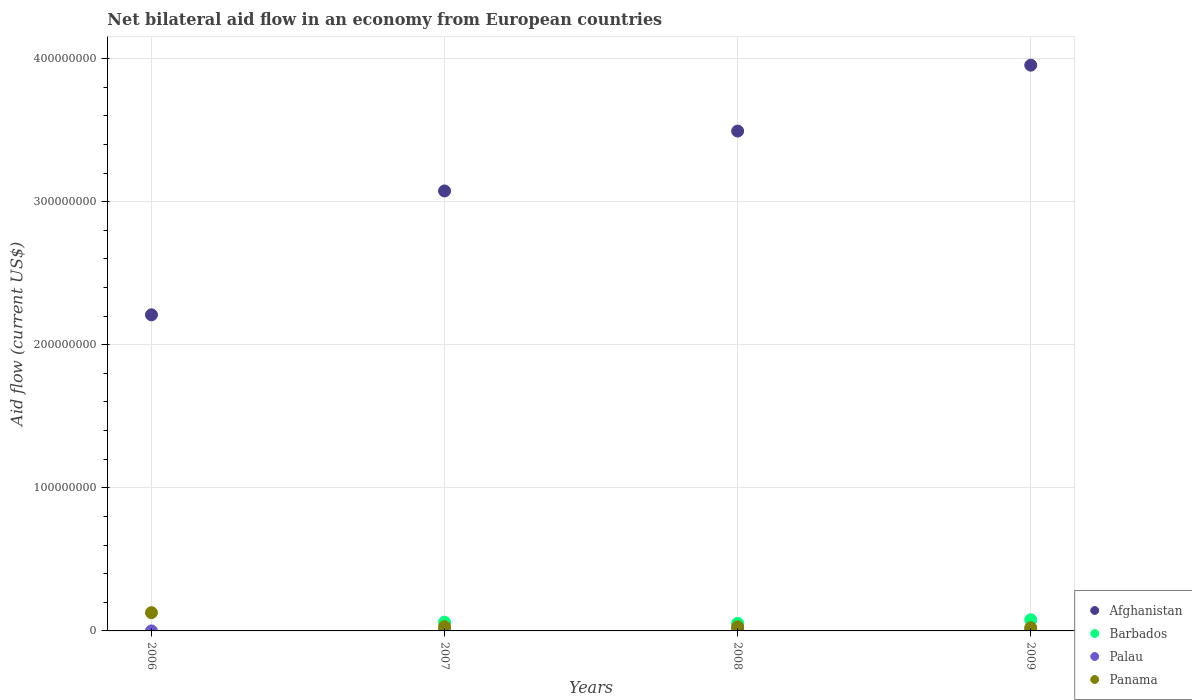How many different coloured dotlines are there?
Offer a very short reply. 4. Is the number of dotlines equal to the number of legend labels?
Offer a very short reply. No. What is the net bilateral aid flow in Palau in 2009?
Provide a short and direct response. 5.90e+05. Across all years, what is the maximum net bilateral aid flow in Palau?
Make the answer very short. 1.28e+06. Across all years, what is the minimum net bilateral aid flow in Afghanistan?
Make the answer very short. 2.21e+08. What is the total net bilateral aid flow in Afghanistan in the graph?
Make the answer very short. 1.27e+09. What is the difference between the net bilateral aid flow in Barbados in 2007 and that in 2009?
Offer a terse response. -1.68e+06. What is the difference between the net bilateral aid flow in Palau in 2009 and the net bilateral aid flow in Barbados in 2008?
Give a very brief answer. -4.70e+06. What is the average net bilateral aid flow in Afghanistan per year?
Offer a very short reply. 3.18e+08. In the year 2009, what is the difference between the net bilateral aid flow in Palau and net bilateral aid flow in Barbados?
Ensure brevity in your answer.  -7.18e+06. In how many years, is the net bilateral aid flow in Panama greater than 360000000 US$?
Keep it short and to the point. 0. What is the ratio of the net bilateral aid flow in Palau in 2007 to that in 2008?
Provide a succinct answer. 0.26. Is the difference between the net bilateral aid flow in Palau in 2007 and 2009 greater than the difference between the net bilateral aid flow in Barbados in 2007 and 2009?
Keep it short and to the point. Yes. What is the difference between the highest and the second highest net bilateral aid flow in Panama?
Ensure brevity in your answer.  9.80e+06. What is the difference between the highest and the lowest net bilateral aid flow in Palau?
Offer a very short reply. 1.26e+06. Is the sum of the net bilateral aid flow in Panama in 2007 and 2009 greater than the maximum net bilateral aid flow in Barbados across all years?
Provide a succinct answer. No. Does the net bilateral aid flow in Palau monotonically increase over the years?
Ensure brevity in your answer.  No. Is the net bilateral aid flow in Palau strictly greater than the net bilateral aid flow in Afghanistan over the years?
Your answer should be very brief. No. What is the difference between two consecutive major ticks on the Y-axis?
Keep it short and to the point. 1.00e+08. Does the graph contain any zero values?
Offer a very short reply. Yes. Where does the legend appear in the graph?
Your response must be concise. Bottom right. How many legend labels are there?
Make the answer very short. 4. How are the legend labels stacked?
Ensure brevity in your answer.  Vertical. What is the title of the graph?
Your answer should be very brief. Net bilateral aid flow in an economy from European countries. Does "Norway" appear as one of the legend labels in the graph?
Provide a succinct answer. No. What is the label or title of the X-axis?
Your answer should be compact. Years. What is the Aid flow (current US$) in Afghanistan in 2006?
Your response must be concise. 2.21e+08. What is the Aid flow (current US$) of Panama in 2006?
Your response must be concise. 1.28e+07. What is the Aid flow (current US$) of Afghanistan in 2007?
Your answer should be compact. 3.07e+08. What is the Aid flow (current US$) in Barbados in 2007?
Give a very brief answer. 6.09e+06. What is the Aid flow (current US$) in Palau in 2007?
Provide a succinct answer. 3.30e+05. What is the Aid flow (current US$) in Panama in 2007?
Offer a very short reply. 2.96e+06. What is the Aid flow (current US$) of Afghanistan in 2008?
Ensure brevity in your answer.  3.49e+08. What is the Aid flow (current US$) in Barbados in 2008?
Ensure brevity in your answer.  5.29e+06. What is the Aid flow (current US$) of Palau in 2008?
Provide a succinct answer. 1.28e+06. What is the Aid flow (current US$) of Panama in 2008?
Ensure brevity in your answer.  2.84e+06. What is the Aid flow (current US$) of Afghanistan in 2009?
Give a very brief answer. 3.95e+08. What is the Aid flow (current US$) of Barbados in 2009?
Your answer should be very brief. 7.77e+06. What is the Aid flow (current US$) of Palau in 2009?
Offer a very short reply. 5.90e+05. What is the Aid flow (current US$) of Panama in 2009?
Ensure brevity in your answer.  2.23e+06. Across all years, what is the maximum Aid flow (current US$) of Afghanistan?
Offer a very short reply. 3.95e+08. Across all years, what is the maximum Aid flow (current US$) in Barbados?
Ensure brevity in your answer.  7.77e+06. Across all years, what is the maximum Aid flow (current US$) of Palau?
Make the answer very short. 1.28e+06. Across all years, what is the maximum Aid flow (current US$) of Panama?
Your answer should be very brief. 1.28e+07. Across all years, what is the minimum Aid flow (current US$) in Afghanistan?
Offer a terse response. 2.21e+08. Across all years, what is the minimum Aid flow (current US$) in Palau?
Your answer should be very brief. 2.00e+04. Across all years, what is the minimum Aid flow (current US$) of Panama?
Your response must be concise. 2.23e+06. What is the total Aid flow (current US$) in Afghanistan in the graph?
Your response must be concise. 1.27e+09. What is the total Aid flow (current US$) of Barbados in the graph?
Offer a very short reply. 1.92e+07. What is the total Aid flow (current US$) in Palau in the graph?
Your answer should be compact. 2.22e+06. What is the total Aid flow (current US$) in Panama in the graph?
Give a very brief answer. 2.08e+07. What is the difference between the Aid flow (current US$) in Afghanistan in 2006 and that in 2007?
Your response must be concise. -8.66e+07. What is the difference between the Aid flow (current US$) in Palau in 2006 and that in 2007?
Make the answer very short. -3.10e+05. What is the difference between the Aid flow (current US$) in Panama in 2006 and that in 2007?
Provide a succinct answer. 9.80e+06. What is the difference between the Aid flow (current US$) in Afghanistan in 2006 and that in 2008?
Offer a very short reply. -1.28e+08. What is the difference between the Aid flow (current US$) of Palau in 2006 and that in 2008?
Provide a short and direct response. -1.26e+06. What is the difference between the Aid flow (current US$) in Panama in 2006 and that in 2008?
Provide a succinct answer. 9.92e+06. What is the difference between the Aid flow (current US$) in Afghanistan in 2006 and that in 2009?
Offer a very short reply. -1.74e+08. What is the difference between the Aid flow (current US$) in Palau in 2006 and that in 2009?
Provide a succinct answer. -5.70e+05. What is the difference between the Aid flow (current US$) of Panama in 2006 and that in 2009?
Your answer should be very brief. 1.05e+07. What is the difference between the Aid flow (current US$) of Afghanistan in 2007 and that in 2008?
Your answer should be very brief. -4.18e+07. What is the difference between the Aid flow (current US$) of Palau in 2007 and that in 2008?
Provide a short and direct response. -9.50e+05. What is the difference between the Aid flow (current US$) of Afghanistan in 2007 and that in 2009?
Offer a terse response. -8.79e+07. What is the difference between the Aid flow (current US$) of Barbados in 2007 and that in 2009?
Offer a terse response. -1.68e+06. What is the difference between the Aid flow (current US$) of Panama in 2007 and that in 2009?
Provide a succinct answer. 7.30e+05. What is the difference between the Aid flow (current US$) of Afghanistan in 2008 and that in 2009?
Your answer should be compact. -4.60e+07. What is the difference between the Aid flow (current US$) of Barbados in 2008 and that in 2009?
Make the answer very short. -2.48e+06. What is the difference between the Aid flow (current US$) in Palau in 2008 and that in 2009?
Provide a succinct answer. 6.90e+05. What is the difference between the Aid flow (current US$) of Afghanistan in 2006 and the Aid flow (current US$) of Barbados in 2007?
Offer a terse response. 2.15e+08. What is the difference between the Aid flow (current US$) of Afghanistan in 2006 and the Aid flow (current US$) of Palau in 2007?
Ensure brevity in your answer.  2.21e+08. What is the difference between the Aid flow (current US$) of Afghanistan in 2006 and the Aid flow (current US$) of Panama in 2007?
Make the answer very short. 2.18e+08. What is the difference between the Aid flow (current US$) in Palau in 2006 and the Aid flow (current US$) in Panama in 2007?
Provide a short and direct response. -2.94e+06. What is the difference between the Aid flow (current US$) in Afghanistan in 2006 and the Aid flow (current US$) in Barbados in 2008?
Provide a succinct answer. 2.16e+08. What is the difference between the Aid flow (current US$) of Afghanistan in 2006 and the Aid flow (current US$) of Palau in 2008?
Offer a terse response. 2.20e+08. What is the difference between the Aid flow (current US$) of Afghanistan in 2006 and the Aid flow (current US$) of Panama in 2008?
Your answer should be very brief. 2.18e+08. What is the difference between the Aid flow (current US$) in Palau in 2006 and the Aid flow (current US$) in Panama in 2008?
Your answer should be compact. -2.82e+06. What is the difference between the Aid flow (current US$) of Afghanistan in 2006 and the Aid flow (current US$) of Barbados in 2009?
Your response must be concise. 2.13e+08. What is the difference between the Aid flow (current US$) of Afghanistan in 2006 and the Aid flow (current US$) of Palau in 2009?
Make the answer very short. 2.20e+08. What is the difference between the Aid flow (current US$) of Afghanistan in 2006 and the Aid flow (current US$) of Panama in 2009?
Your answer should be very brief. 2.19e+08. What is the difference between the Aid flow (current US$) in Palau in 2006 and the Aid flow (current US$) in Panama in 2009?
Provide a short and direct response. -2.21e+06. What is the difference between the Aid flow (current US$) of Afghanistan in 2007 and the Aid flow (current US$) of Barbados in 2008?
Offer a very short reply. 3.02e+08. What is the difference between the Aid flow (current US$) in Afghanistan in 2007 and the Aid flow (current US$) in Palau in 2008?
Offer a terse response. 3.06e+08. What is the difference between the Aid flow (current US$) in Afghanistan in 2007 and the Aid flow (current US$) in Panama in 2008?
Provide a succinct answer. 3.05e+08. What is the difference between the Aid flow (current US$) in Barbados in 2007 and the Aid flow (current US$) in Palau in 2008?
Your answer should be very brief. 4.81e+06. What is the difference between the Aid flow (current US$) in Barbados in 2007 and the Aid flow (current US$) in Panama in 2008?
Ensure brevity in your answer.  3.25e+06. What is the difference between the Aid flow (current US$) of Palau in 2007 and the Aid flow (current US$) of Panama in 2008?
Give a very brief answer. -2.51e+06. What is the difference between the Aid flow (current US$) of Afghanistan in 2007 and the Aid flow (current US$) of Barbados in 2009?
Keep it short and to the point. 3.00e+08. What is the difference between the Aid flow (current US$) in Afghanistan in 2007 and the Aid flow (current US$) in Palau in 2009?
Provide a short and direct response. 3.07e+08. What is the difference between the Aid flow (current US$) of Afghanistan in 2007 and the Aid flow (current US$) of Panama in 2009?
Your response must be concise. 3.05e+08. What is the difference between the Aid flow (current US$) of Barbados in 2007 and the Aid flow (current US$) of Palau in 2009?
Give a very brief answer. 5.50e+06. What is the difference between the Aid flow (current US$) of Barbados in 2007 and the Aid flow (current US$) of Panama in 2009?
Ensure brevity in your answer.  3.86e+06. What is the difference between the Aid flow (current US$) of Palau in 2007 and the Aid flow (current US$) of Panama in 2009?
Give a very brief answer. -1.90e+06. What is the difference between the Aid flow (current US$) in Afghanistan in 2008 and the Aid flow (current US$) in Barbados in 2009?
Your response must be concise. 3.42e+08. What is the difference between the Aid flow (current US$) of Afghanistan in 2008 and the Aid flow (current US$) of Palau in 2009?
Ensure brevity in your answer.  3.49e+08. What is the difference between the Aid flow (current US$) in Afghanistan in 2008 and the Aid flow (current US$) in Panama in 2009?
Your response must be concise. 3.47e+08. What is the difference between the Aid flow (current US$) in Barbados in 2008 and the Aid flow (current US$) in Palau in 2009?
Your answer should be very brief. 4.70e+06. What is the difference between the Aid flow (current US$) of Barbados in 2008 and the Aid flow (current US$) of Panama in 2009?
Offer a very short reply. 3.06e+06. What is the difference between the Aid flow (current US$) of Palau in 2008 and the Aid flow (current US$) of Panama in 2009?
Offer a very short reply. -9.50e+05. What is the average Aid flow (current US$) in Afghanistan per year?
Offer a terse response. 3.18e+08. What is the average Aid flow (current US$) of Barbados per year?
Ensure brevity in your answer.  4.79e+06. What is the average Aid flow (current US$) of Palau per year?
Provide a short and direct response. 5.55e+05. What is the average Aid flow (current US$) of Panama per year?
Offer a very short reply. 5.20e+06. In the year 2006, what is the difference between the Aid flow (current US$) of Afghanistan and Aid flow (current US$) of Palau?
Keep it short and to the point. 2.21e+08. In the year 2006, what is the difference between the Aid flow (current US$) in Afghanistan and Aid flow (current US$) in Panama?
Your answer should be very brief. 2.08e+08. In the year 2006, what is the difference between the Aid flow (current US$) in Palau and Aid flow (current US$) in Panama?
Your answer should be compact. -1.27e+07. In the year 2007, what is the difference between the Aid flow (current US$) in Afghanistan and Aid flow (current US$) in Barbados?
Provide a succinct answer. 3.01e+08. In the year 2007, what is the difference between the Aid flow (current US$) in Afghanistan and Aid flow (current US$) in Palau?
Provide a succinct answer. 3.07e+08. In the year 2007, what is the difference between the Aid flow (current US$) of Afghanistan and Aid flow (current US$) of Panama?
Your answer should be very brief. 3.04e+08. In the year 2007, what is the difference between the Aid flow (current US$) in Barbados and Aid flow (current US$) in Palau?
Ensure brevity in your answer.  5.76e+06. In the year 2007, what is the difference between the Aid flow (current US$) in Barbados and Aid flow (current US$) in Panama?
Provide a short and direct response. 3.13e+06. In the year 2007, what is the difference between the Aid flow (current US$) in Palau and Aid flow (current US$) in Panama?
Your response must be concise. -2.63e+06. In the year 2008, what is the difference between the Aid flow (current US$) of Afghanistan and Aid flow (current US$) of Barbados?
Keep it short and to the point. 3.44e+08. In the year 2008, what is the difference between the Aid flow (current US$) of Afghanistan and Aid flow (current US$) of Palau?
Your response must be concise. 3.48e+08. In the year 2008, what is the difference between the Aid flow (current US$) in Afghanistan and Aid flow (current US$) in Panama?
Your answer should be compact. 3.46e+08. In the year 2008, what is the difference between the Aid flow (current US$) of Barbados and Aid flow (current US$) of Palau?
Offer a very short reply. 4.01e+06. In the year 2008, what is the difference between the Aid flow (current US$) of Barbados and Aid flow (current US$) of Panama?
Give a very brief answer. 2.45e+06. In the year 2008, what is the difference between the Aid flow (current US$) of Palau and Aid flow (current US$) of Panama?
Your answer should be very brief. -1.56e+06. In the year 2009, what is the difference between the Aid flow (current US$) of Afghanistan and Aid flow (current US$) of Barbados?
Your answer should be very brief. 3.88e+08. In the year 2009, what is the difference between the Aid flow (current US$) of Afghanistan and Aid flow (current US$) of Palau?
Your response must be concise. 3.95e+08. In the year 2009, what is the difference between the Aid flow (current US$) in Afghanistan and Aid flow (current US$) in Panama?
Ensure brevity in your answer.  3.93e+08. In the year 2009, what is the difference between the Aid flow (current US$) of Barbados and Aid flow (current US$) of Palau?
Ensure brevity in your answer.  7.18e+06. In the year 2009, what is the difference between the Aid flow (current US$) of Barbados and Aid flow (current US$) of Panama?
Offer a very short reply. 5.54e+06. In the year 2009, what is the difference between the Aid flow (current US$) in Palau and Aid flow (current US$) in Panama?
Ensure brevity in your answer.  -1.64e+06. What is the ratio of the Aid flow (current US$) in Afghanistan in 2006 to that in 2007?
Offer a terse response. 0.72. What is the ratio of the Aid flow (current US$) of Palau in 2006 to that in 2007?
Make the answer very short. 0.06. What is the ratio of the Aid flow (current US$) of Panama in 2006 to that in 2007?
Your answer should be compact. 4.31. What is the ratio of the Aid flow (current US$) of Afghanistan in 2006 to that in 2008?
Offer a very short reply. 0.63. What is the ratio of the Aid flow (current US$) of Palau in 2006 to that in 2008?
Offer a terse response. 0.02. What is the ratio of the Aid flow (current US$) in Panama in 2006 to that in 2008?
Keep it short and to the point. 4.49. What is the ratio of the Aid flow (current US$) in Afghanistan in 2006 to that in 2009?
Ensure brevity in your answer.  0.56. What is the ratio of the Aid flow (current US$) in Palau in 2006 to that in 2009?
Give a very brief answer. 0.03. What is the ratio of the Aid flow (current US$) of Panama in 2006 to that in 2009?
Provide a short and direct response. 5.72. What is the ratio of the Aid flow (current US$) in Afghanistan in 2007 to that in 2008?
Ensure brevity in your answer.  0.88. What is the ratio of the Aid flow (current US$) in Barbados in 2007 to that in 2008?
Ensure brevity in your answer.  1.15. What is the ratio of the Aid flow (current US$) of Palau in 2007 to that in 2008?
Your answer should be compact. 0.26. What is the ratio of the Aid flow (current US$) in Panama in 2007 to that in 2008?
Offer a terse response. 1.04. What is the ratio of the Aid flow (current US$) of Afghanistan in 2007 to that in 2009?
Offer a very short reply. 0.78. What is the ratio of the Aid flow (current US$) in Barbados in 2007 to that in 2009?
Offer a terse response. 0.78. What is the ratio of the Aid flow (current US$) of Palau in 2007 to that in 2009?
Your response must be concise. 0.56. What is the ratio of the Aid flow (current US$) of Panama in 2007 to that in 2009?
Your answer should be compact. 1.33. What is the ratio of the Aid flow (current US$) in Afghanistan in 2008 to that in 2009?
Keep it short and to the point. 0.88. What is the ratio of the Aid flow (current US$) in Barbados in 2008 to that in 2009?
Provide a succinct answer. 0.68. What is the ratio of the Aid flow (current US$) of Palau in 2008 to that in 2009?
Provide a short and direct response. 2.17. What is the ratio of the Aid flow (current US$) in Panama in 2008 to that in 2009?
Offer a terse response. 1.27. What is the difference between the highest and the second highest Aid flow (current US$) of Afghanistan?
Provide a short and direct response. 4.60e+07. What is the difference between the highest and the second highest Aid flow (current US$) of Barbados?
Your answer should be very brief. 1.68e+06. What is the difference between the highest and the second highest Aid flow (current US$) of Palau?
Offer a terse response. 6.90e+05. What is the difference between the highest and the second highest Aid flow (current US$) of Panama?
Offer a very short reply. 9.80e+06. What is the difference between the highest and the lowest Aid flow (current US$) in Afghanistan?
Ensure brevity in your answer.  1.74e+08. What is the difference between the highest and the lowest Aid flow (current US$) of Barbados?
Ensure brevity in your answer.  7.77e+06. What is the difference between the highest and the lowest Aid flow (current US$) of Palau?
Your answer should be compact. 1.26e+06. What is the difference between the highest and the lowest Aid flow (current US$) of Panama?
Keep it short and to the point. 1.05e+07. 